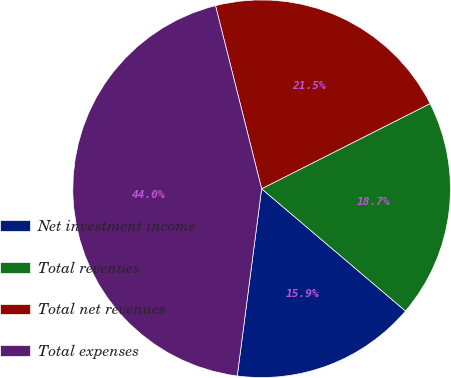Convert chart. <chart><loc_0><loc_0><loc_500><loc_500><pie_chart><fcel>Net investment income<fcel>Total revenues<fcel>Total net revenues<fcel>Total expenses<nl><fcel>15.85%<fcel>18.66%<fcel>21.48%<fcel>44.01%<nl></chart> 